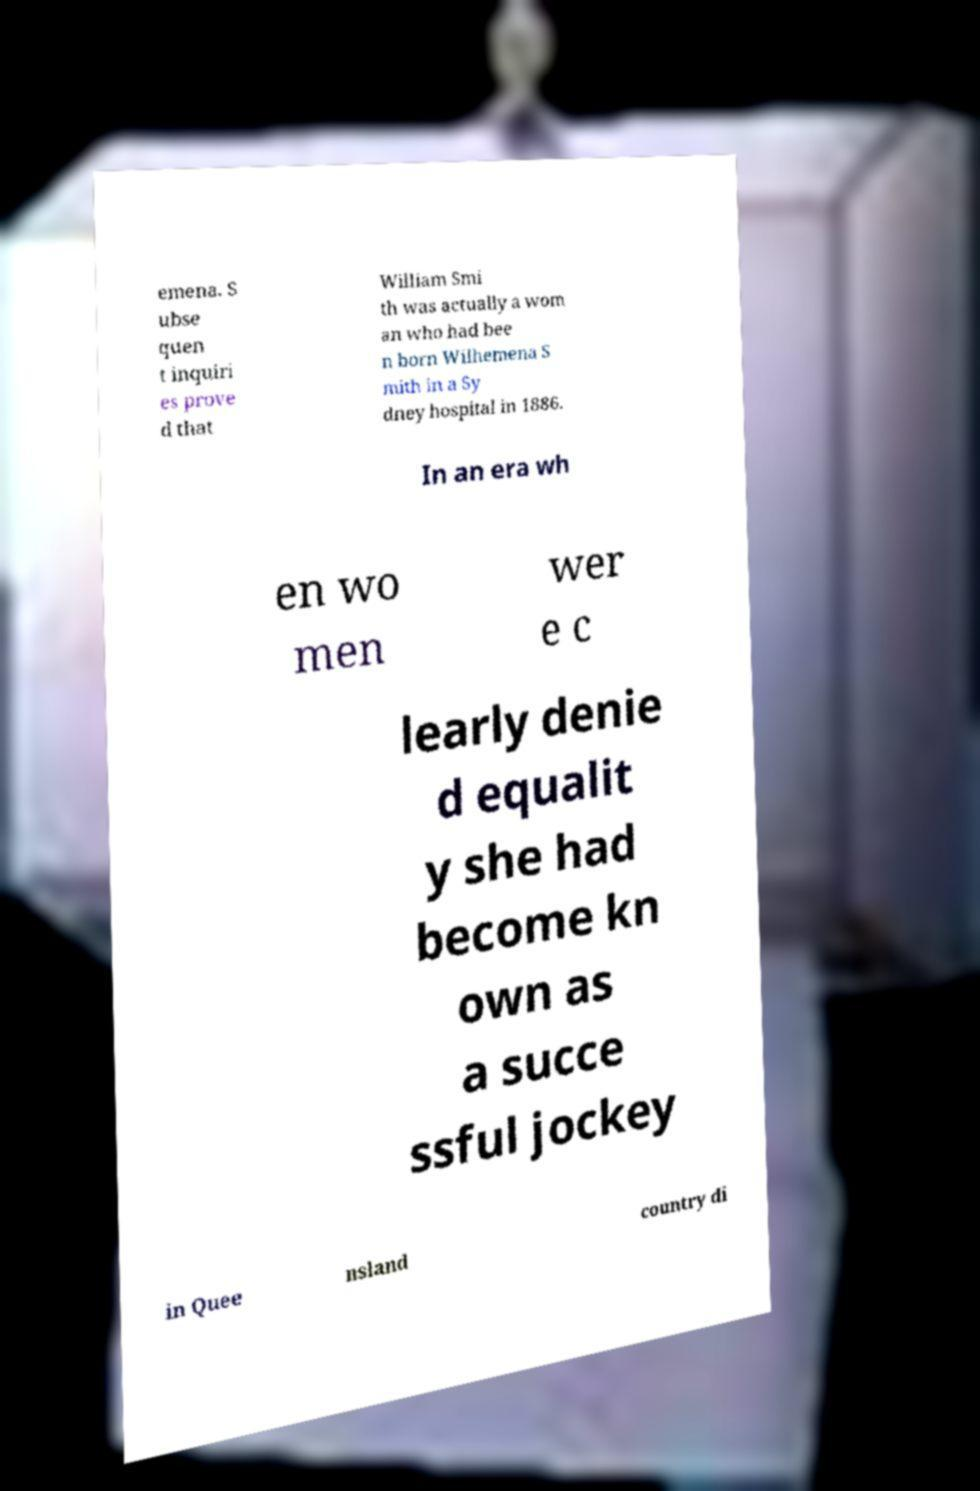Could you assist in decoding the text presented in this image and type it out clearly? emena. S ubse quen t inquiri es prove d that William Smi th was actually a wom an who had bee n born Wilhemena S mith in a Sy dney hospital in 1886. In an era wh en wo men wer e c learly denie d equalit y she had become kn own as a succe ssful jockey in Quee nsland country di 